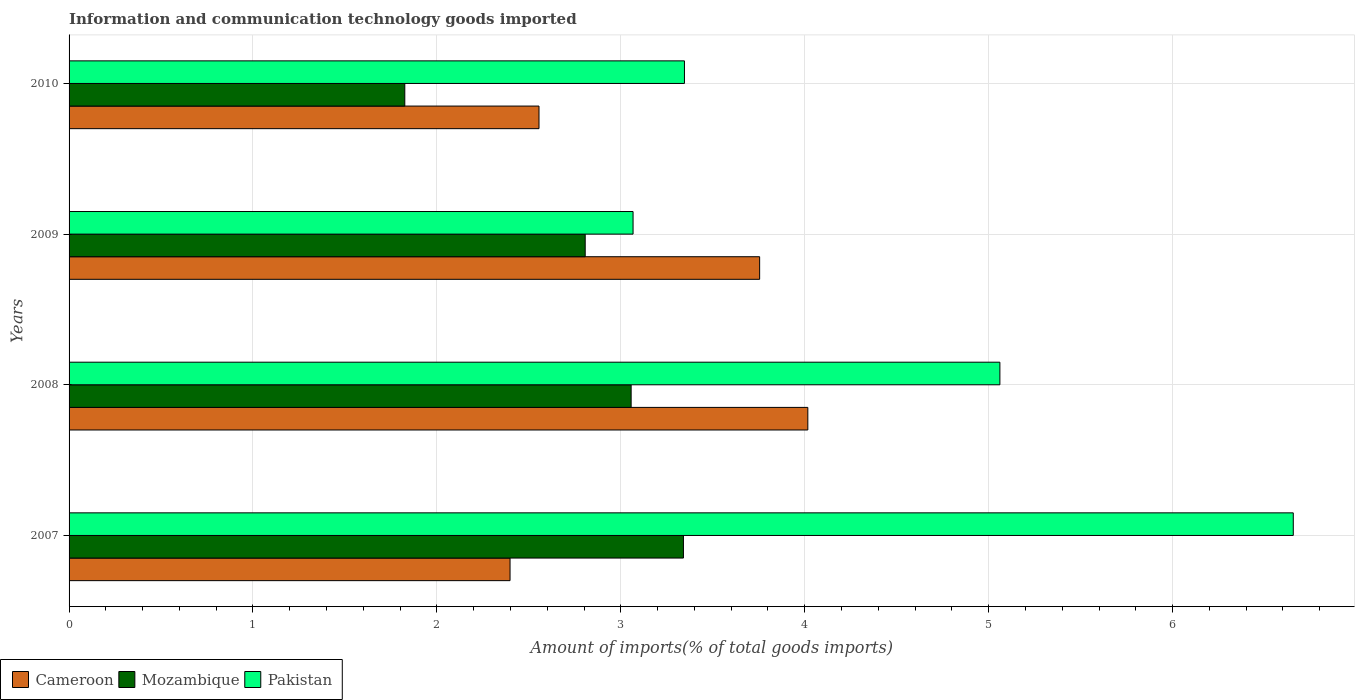How many groups of bars are there?
Provide a succinct answer. 4. What is the label of the 1st group of bars from the top?
Give a very brief answer. 2010. In how many cases, is the number of bars for a given year not equal to the number of legend labels?
Make the answer very short. 0. What is the amount of goods imported in Pakistan in 2008?
Your answer should be compact. 5.06. Across all years, what is the maximum amount of goods imported in Cameroon?
Provide a succinct answer. 4.02. Across all years, what is the minimum amount of goods imported in Mozambique?
Your response must be concise. 1.83. In which year was the amount of goods imported in Cameroon maximum?
Keep it short and to the point. 2008. What is the total amount of goods imported in Mozambique in the graph?
Your response must be concise. 11.03. What is the difference between the amount of goods imported in Pakistan in 2007 and that in 2010?
Offer a terse response. 3.31. What is the difference between the amount of goods imported in Pakistan in 2009 and the amount of goods imported in Cameroon in 2008?
Offer a terse response. -0.95. What is the average amount of goods imported in Cameroon per year?
Offer a terse response. 3.18. In the year 2007, what is the difference between the amount of goods imported in Cameroon and amount of goods imported in Mozambique?
Give a very brief answer. -0.94. What is the ratio of the amount of goods imported in Cameroon in 2007 to that in 2010?
Give a very brief answer. 0.94. Is the amount of goods imported in Pakistan in 2007 less than that in 2010?
Ensure brevity in your answer.  No. What is the difference between the highest and the second highest amount of goods imported in Cameroon?
Your answer should be compact. 0.26. What is the difference between the highest and the lowest amount of goods imported in Cameroon?
Your response must be concise. 1.62. In how many years, is the amount of goods imported in Mozambique greater than the average amount of goods imported in Mozambique taken over all years?
Your answer should be compact. 3. Is the sum of the amount of goods imported in Cameroon in 2007 and 2010 greater than the maximum amount of goods imported in Mozambique across all years?
Keep it short and to the point. Yes. What does the 3rd bar from the top in 2009 represents?
Ensure brevity in your answer.  Cameroon. What does the 1st bar from the bottom in 2009 represents?
Keep it short and to the point. Cameroon. How many bars are there?
Make the answer very short. 12. Are all the bars in the graph horizontal?
Offer a terse response. Yes. How many years are there in the graph?
Your answer should be very brief. 4. Does the graph contain any zero values?
Provide a succinct answer. No. Does the graph contain grids?
Offer a terse response. Yes. How are the legend labels stacked?
Your answer should be very brief. Horizontal. What is the title of the graph?
Your answer should be compact. Information and communication technology goods imported. What is the label or title of the X-axis?
Keep it short and to the point. Amount of imports(% of total goods imports). What is the label or title of the Y-axis?
Your answer should be compact. Years. What is the Amount of imports(% of total goods imports) in Cameroon in 2007?
Keep it short and to the point. 2.4. What is the Amount of imports(% of total goods imports) in Mozambique in 2007?
Offer a terse response. 3.34. What is the Amount of imports(% of total goods imports) of Pakistan in 2007?
Offer a very short reply. 6.66. What is the Amount of imports(% of total goods imports) in Cameroon in 2008?
Your answer should be compact. 4.02. What is the Amount of imports(% of total goods imports) in Mozambique in 2008?
Give a very brief answer. 3.06. What is the Amount of imports(% of total goods imports) in Pakistan in 2008?
Provide a succinct answer. 5.06. What is the Amount of imports(% of total goods imports) in Cameroon in 2009?
Provide a short and direct response. 3.75. What is the Amount of imports(% of total goods imports) in Mozambique in 2009?
Give a very brief answer. 2.81. What is the Amount of imports(% of total goods imports) of Pakistan in 2009?
Give a very brief answer. 3.07. What is the Amount of imports(% of total goods imports) of Cameroon in 2010?
Ensure brevity in your answer.  2.56. What is the Amount of imports(% of total goods imports) in Mozambique in 2010?
Your response must be concise. 1.83. What is the Amount of imports(% of total goods imports) of Pakistan in 2010?
Make the answer very short. 3.35. Across all years, what is the maximum Amount of imports(% of total goods imports) of Cameroon?
Offer a very short reply. 4.02. Across all years, what is the maximum Amount of imports(% of total goods imports) in Mozambique?
Offer a very short reply. 3.34. Across all years, what is the maximum Amount of imports(% of total goods imports) in Pakistan?
Your answer should be very brief. 6.66. Across all years, what is the minimum Amount of imports(% of total goods imports) of Cameroon?
Offer a terse response. 2.4. Across all years, what is the minimum Amount of imports(% of total goods imports) of Mozambique?
Keep it short and to the point. 1.83. Across all years, what is the minimum Amount of imports(% of total goods imports) of Pakistan?
Offer a terse response. 3.07. What is the total Amount of imports(% of total goods imports) in Cameroon in the graph?
Provide a short and direct response. 12.72. What is the total Amount of imports(% of total goods imports) of Mozambique in the graph?
Offer a very short reply. 11.03. What is the total Amount of imports(% of total goods imports) of Pakistan in the graph?
Your response must be concise. 18.13. What is the difference between the Amount of imports(% of total goods imports) in Cameroon in 2007 and that in 2008?
Your response must be concise. -1.62. What is the difference between the Amount of imports(% of total goods imports) in Mozambique in 2007 and that in 2008?
Offer a very short reply. 0.28. What is the difference between the Amount of imports(% of total goods imports) in Pakistan in 2007 and that in 2008?
Provide a short and direct response. 1.6. What is the difference between the Amount of imports(% of total goods imports) of Cameroon in 2007 and that in 2009?
Ensure brevity in your answer.  -1.36. What is the difference between the Amount of imports(% of total goods imports) in Mozambique in 2007 and that in 2009?
Provide a short and direct response. 0.53. What is the difference between the Amount of imports(% of total goods imports) in Pakistan in 2007 and that in 2009?
Ensure brevity in your answer.  3.59. What is the difference between the Amount of imports(% of total goods imports) in Cameroon in 2007 and that in 2010?
Offer a very short reply. -0.16. What is the difference between the Amount of imports(% of total goods imports) in Mozambique in 2007 and that in 2010?
Provide a succinct answer. 1.51. What is the difference between the Amount of imports(% of total goods imports) of Pakistan in 2007 and that in 2010?
Provide a succinct answer. 3.31. What is the difference between the Amount of imports(% of total goods imports) of Cameroon in 2008 and that in 2009?
Your response must be concise. 0.26. What is the difference between the Amount of imports(% of total goods imports) of Mozambique in 2008 and that in 2009?
Offer a very short reply. 0.25. What is the difference between the Amount of imports(% of total goods imports) of Pakistan in 2008 and that in 2009?
Your answer should be very brief. 1.99. What is the difference between the Amount of imports(% of total goods imports) in Cameroon in 2008 and that in 2010?
Your answer should be compact. 1.46. What is the difference between the Amount of imports(% of total goods imports) in Mozambique in 2008 and that in 2010?
Your answer should be very brief. 1.23. What is the difference between the Amount of imports(% of total goods imports) in Pakistan in 2008 and that in 2010?
Ensure brevity in your answer.  1.72. What is the difference between the Amount of imports(% of total goods imports) of Cameroon in 2009 and that in 2010?
Your response must be concise. 1.2. What is the difference between the Amount of imports(% of total goods imports) in Mozambique in 2009 and that in 2010?
Keep it short and to the point. 0.98. What is the difference between the Amount of imports(% of total goods imports) in Pakistan in 2009 and that in 2010?
Make the answer very short. -0.28. What is the difference between the Amount of imports(% of total goods imports) of Cameroon in 2007 and the Amount of imports(% of total goods imports) of Mozambique in 2008?
Ensure brevity in your answer.  -0.66. What is the difference between the Amount of imports(% of total goods imports) in Cameroon in 2007 and the Amount of imports(% of total goods imports) in Pakistan in 2008?
Ensure brevity in your answer.  -2.66. What is the difference between the Amount of imports(% of total goods imports) of Mozambique in 2007 and the Amount of imports(% of total goods imports) of Pakistan in 2008?
Your answer should be compact. -1.72. What is the difference between the Amount of imports(% of total goods imports) in Cameroon in 2007 and the Amount of imports(% of total goods imports) in Mozambique in 2009?
Provide a short and direct response. -0.41. What is the difference between the Amount of imports(% of total goods imports) of Cameroon in 2007 and the Amount of imports(% of total goods imports) of Pakistan in 2009?
Provide a succinct answer. -0.67. What is the difference between the Amount of imports(% of total goods imports) of Mozambique in 2007 and the Amount of imports(% of total goods imports) of Pakistan in 2009?
Keep it short and to the point. 0.27. What is the difference between the Amount of imports(% of total goods imports) in Cameroon in 2007 and the Amount of imports(% of total goods imports) in Mozambique in 2010?
Give a very brief answer. 0.57. What is the difference between the Amount of imports(% of total goods imports) in Cameroon in 2007 and the Amount of imports(% of total goods imports) in Pakistan in 2010?
Keep it short and to the point. -0.95. What is the difference between the Amount of imports(% of total goods imports) in Mozambique in 2007 and the Amount of imports(% of total goods imports) in Pakistan in 2010?
Provide a short and direct response. -0.01. What is the difference between the Amount of imports(% of total goods imports) in Cameroon in 2008 and the Amount of imports(% of total goods imports) in Mozambique in 2009?
Make the answer very short. 1.21. What is the difference between the Amount of imports(% of total goods imports) of Cameroon in 2008 and the Amount of imports(% of total goods imports) of Pakistan in 2009?
Your answer should be compact. 0.95. What is the difference between the Amount of imports(% of total goods imports) of Mozambique in 2008 and the Amount of imports(% of total goods imports) of Pakistan in 2009?
Offer a terse response. -0.01. What is the difference between the Amount of imports(% of total goods imports) in Cameroon in 2008 and the Amount of imports(% of total goods imports) in Mozambique in 2010?
Provide a short and direct response. 2.19. What is the difference between the Amount of imports(% of total goods imports) of Cameroon in 2008 and the Amount of imports(% of total goods imports) of Pakistan in 2010?
Keep it short and to the point. 0.67. What is the difference between the Amount of imports(% of total goods imports) in Mozambique in 2008 and the Amount of imports(% of total goods imports) in Pakistan in 2010?
Provide a succinct answer. -0.29. What is the difference between the Amount of imports(% of total goods imports) in Cameroon in 2009 and the Amount of imports(% of total goods imports) in Mozambique in 2010?
Offer a very short reply. 1.93. What is the difference between the Amount of imports(% of total goods imports) in Cameroon in 2009 and the Amount of imports(% of total goods imports) in Pakistan in 2010?
Keep it short and to the point. 0.41. What is the difference between the Amount of imports(% of total goods imports) in Mozambique in 2009 and the Amount of imports(% of total goods imports) in Pakistan in 2010?
Keep it short and to the point. -0.54. What is the average Amount of imports(% of total goods imports) of Cameroon per year?
Offer a terse response. 3.18. What is the average Amount of imports(% of total goods imports) of Mozambique per year?
Offer a terse response. 2.76. What is the average Amount of imports(% of total goods imports) in Pakistan per year?
Offer a very short reply. 4.53. In the year 2007, what is the difference between the Amount of imports(% of total goods imports) of Cameroon and Amount of imports(% of total goods imports) of Mozambique?
Provide a succinct answer. -0.94. In the year 2007, what is the difference between the Amount of imports(% of total goods imports) of Cameroon and Amount of imports(% of total goods imports) of Pakistan?
Give a very brief answer. -4.26. In the year 2007, what is the difference between the Amount of imports(% of total goods imports) in Mozambique and Amount of imports(% of total goods imports) in Pakistan?
Provide a short and direct response. -3.32. In the year 2008, what is the difference between the Amount of imports(% of total goods imports) of Cameroon and Amount of imports(% of total goods imports) of Mozambique?
Give a very brief answer. 0.96. In the year 2008, what is the difference between the Amount of imports(% of total goods imports) in Cameroon and Amount of imports(% of total goods imports) in Pakistan?
Your answer should be very brief. -1.04. In the year 2008, what is the difference between the Amount of imports(% of total goods imports) in Mozambique and Amount of imports(% of total goods imports) in Pakistan?
Your answer should be very brief. -2.01. In the year 2009, what is the difference between the Amount of imports(% of total goods imports) of Cameroon and Amount of imports(% of total goods imports) of Mozambique?
Make the answer very short. 0.95. In the year 2009, what is the difference between the Amount of imports(% of total goods imports) of Cameroon and Amount of imports(% of total goods imports) of Pakistan?
Your response must be concise. 0.69. In the year 2009, what is the difference between the Amount of imports(% of total goods imports) of Mozambique and Amount of imports(% of total goods imports) of Pakistan?
Your response must be concise. -0.26. In the year 2010, what is the difference between the Amount of imports(% of total goods imports) of Cameroon and Amount of imports(% of total goods imports) of Mozambique?
Your answer should be compact. 0.73. In the year 2010, what is the difference between the Amount of imports(% of total goods imports) in Cameroon and Amount of imports(% of total goods imports) in Pakistan?
Your answer should be very brief. -0.79. In the year 2010, what is the difference between the Amount of imports(% of total goods imports) in Mozambique and Amount of imports(% of total goods imports) in Pakistan?
Provide a succinct answer. -1.52. What is the ratio of the Amount of imports(% of total goods imports) of Cameroon in 2007 to that in 2008?
Give a very brief answer. 0.6. What is the ratio of the Amount of imports(% of total goods imports) in Mozambique in 2007 to that in 2008?
Keep it short and to the point. 1.09. What is the ratio of the Amount of imports(% of total goods imports) in Pakistan in 2007 to that in 2008?
Ensure brevity in your answer.  1.32. What is the ratio of the Amount of imports(% of total goods imports) in Cameroon in 2007 to that in 2009?
Your response must be concise. 0.64. What is the ratio of the Amount of imports(% of total goods imports) in Mozambique in 2007 to that in 2009?
Ensure brevity in your answer.  1.19. What is the ratio of the Amount of imports(% of total goods imports) of Pakistan in 2007 to that in 2009?
Ensure brevity in your answer.  2.17. What is the ratio of the Amount of imports(% of total goods imports) of Cameroon in 2007 to that in 2010?
Provide a short and direct response. 0.94. What is the ratio of the Amount of imports(% of total goods imports) of Mozambique in 2007 to that in 2010?
Ensure brevity in your answer.  1.83. What is the ratio of the Amount of imports(% of total goods imports) of Pakistan in 2007 to that in 2010?
Provide a short and direct response. 1.99. What is the ratio of the Amount of imports(% of total goods imports) in Cameroon in 2008 to that in 2009?
Your answer should be very brief. 1.07. What is the ratio of the Amount of imports(% of total goods imports) of Mozambique in 2008 to that in 2009?
Offer a terse response. 1.09. What is the ratio of the Amount of imports(% of total goods imports) in Pakistan in 2008 to that in 2009?
Offer a terse response. 1.65. What is the ratio of the Amount of imports(% of total goods imports) in Cameroon in 2008 to that in 2010?
Your response must be concise. 1.57. What is the ratio of the Amount of imports(% of total goods imports) of Mozambique in 2008 to that in 2010?
Keep it short and to the point. 1.67. What is the ratio of the Amount of imports(% of total goods imports) of Pakistan in 2008 to that in 2010?
Provide a succinct answer. 1.51. What is the ratio of the Amount of imports(% of total goods imports) of Cameroon in 2009 to that in 2010?
Your answer should be compact. 1.47. What is the ratio of the Amount of imports(% of total goods imports) in Mozambique in 2009 to that in 2010?
Give a very brief answer. 1.54. What is the ratio of the Amount of imports(% of total goods imports) in Pakistan in 2009 to that in 2010?
Your answer should be compact. 0.92. What is the difference between the highest and the second highest Amount of imports(% of total goods imports) in Cameroon?
Keep it short and to the point. 0.26. What is the difference between the highest and the second highest Amount of imports(% of total goods imports) in Mozambique?
Keep it short and to the point. 0.28. What is the difference between the highest and the second highest Amount of imports(% of total goods imports) of Pakistan?
Offer a very short reply. 1.6. What is the difference between the highest and the lowest Amount of imports(% of total goods imports) of Cameroon?
Offer a terse response. 1.62. What is the difference between the highest and the lowest Amount of imports(% of total goods imports) of Mozambique?
Your response must be concise. 1.51. What is the difference between the highest and the lowest Amount of imports(% of total goods imports) in Pakistan?
Ensure brevity in your answer.  3.59. 